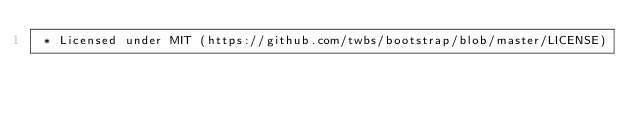Convert code to text. <code><loc_0><loc_0><loc_500><loc_500><_CSS_> * Licensed under MIT (https://github.com/twbs/bootstrap/blob/master/LICENSE)</code> 